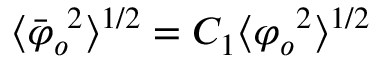Convert formula to latex. <formula><loc_0><loc_0><loc_500><loc_500>\langle { \bar { \varphi } _ { o } } ^ { 2 } \rangle ^ { 1 / 2 } = C _ { 1 } \langle { \varphi _ { o } } ^ { 2 } \rangle ^ { 1 / 2 }</formula> 